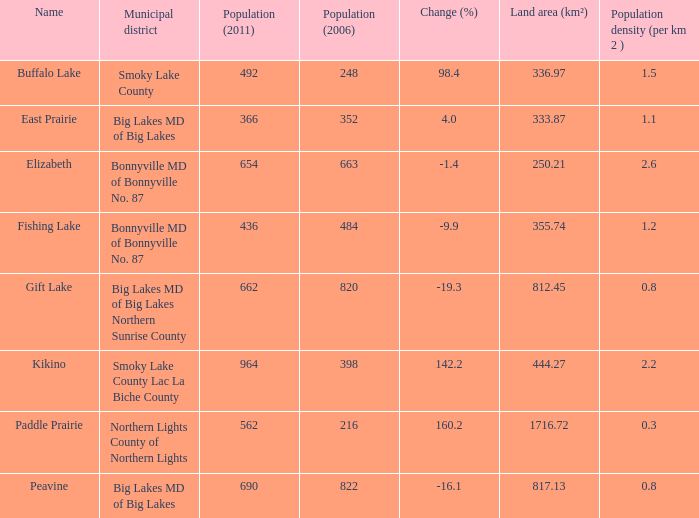How many individuals are there per square kilometer in smoky lake county? 1.5. 